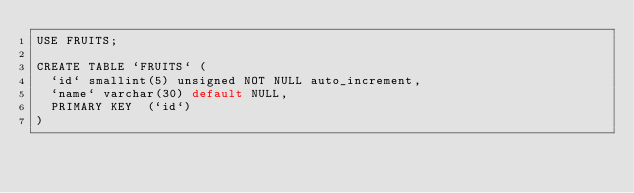<code> <loc_0><loc_0><loc_500><loc_500><_SQL_>USE FRUITS;

CREATE TABLE `FRUITS` (
  `id` smallint(5) unsigned NOT NULL auto_increment,
  `name` varchar(30) default NULL,
  PRIMARY KEY  (`id`)
) 
</code> 